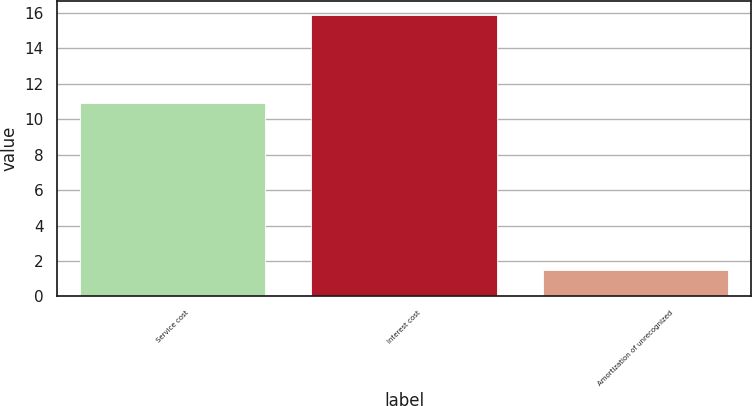<chart> <loc_0><loc_0><loc_500><loc_500><bar_chart><fcel>Service cost<fcel>Interest cost<fcel>Amortization of unrecognized<nl><fcel>10.9<fcel>15.9<fcel>1.5<nl></chart> 